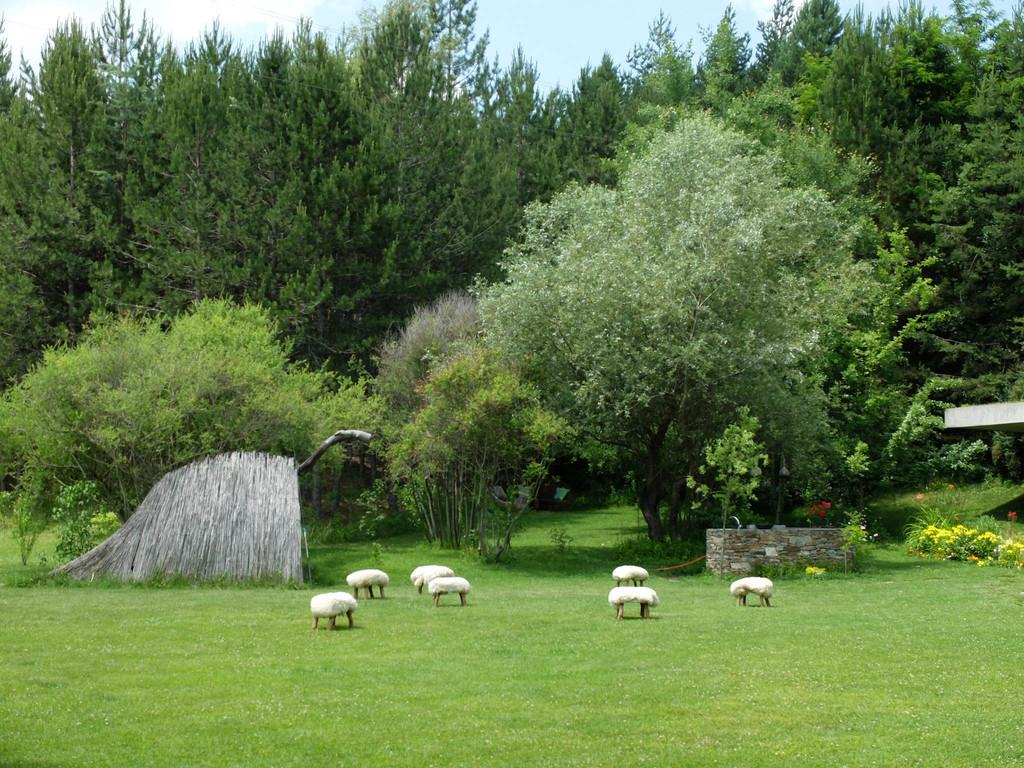What type of surface is visible in the image? There is a ground in the image. What type of vegetation can be seen in the image? There are trees and plants in the image. What type of furniture is present in the image? There are tables in the image. What else can be seen in the image besides the mentioned objects? There are other objects visible in the image. What is visible at the top of the image? The sky is visible at the top of the image. Where is the vase located in the image? There is no vase present in the image. What type of magical activity is happening in the image? There is no magic or magical activity present in the image. 